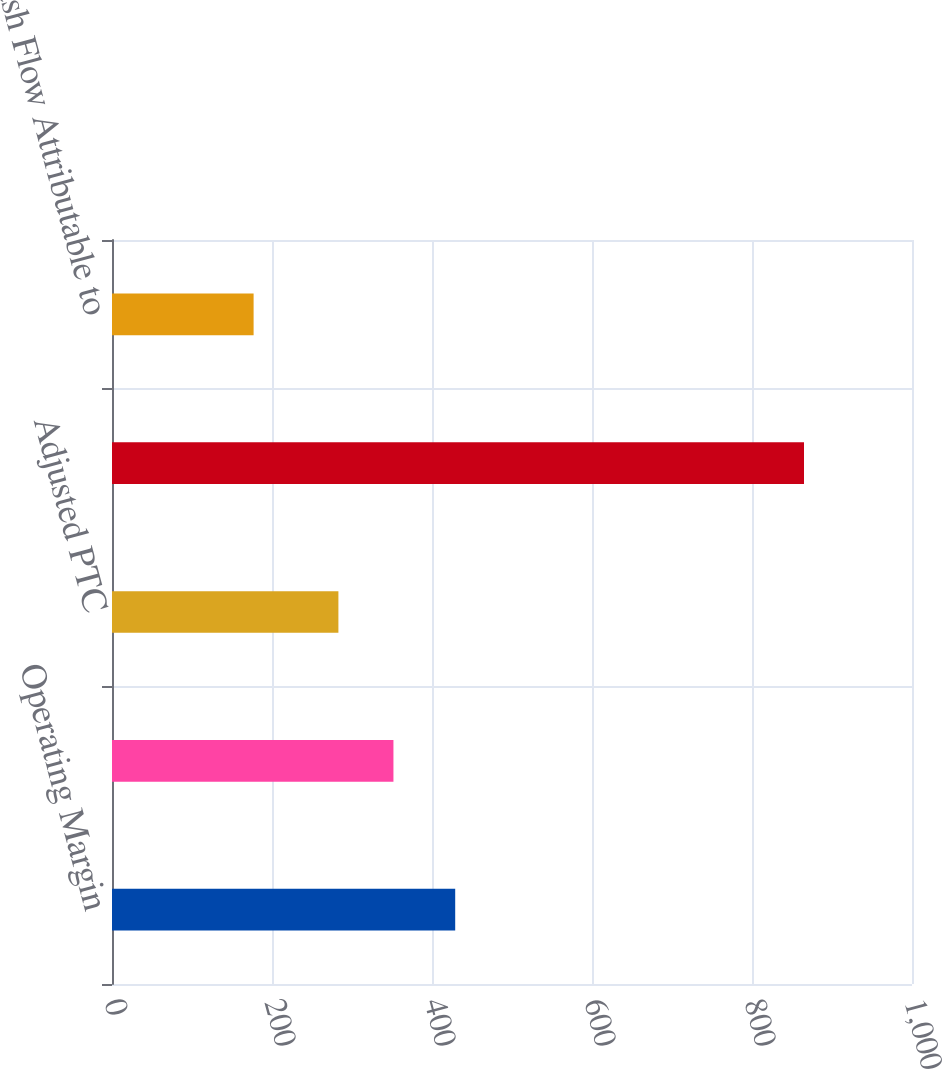Convert chart. <chart><loc_0><loc_0><loc_500><loc_500><bar_chart><fcel>Operating Margin<fcel>Adjusted Operating Margin<fcel>Adjusted PTC<fcel>Free Cash Flow<fcel>Free Cash Flow Attributable to<nl><fcel>429<fcel>351.8<fcel>283<fcel>865<fcel>177<nl></chart> 